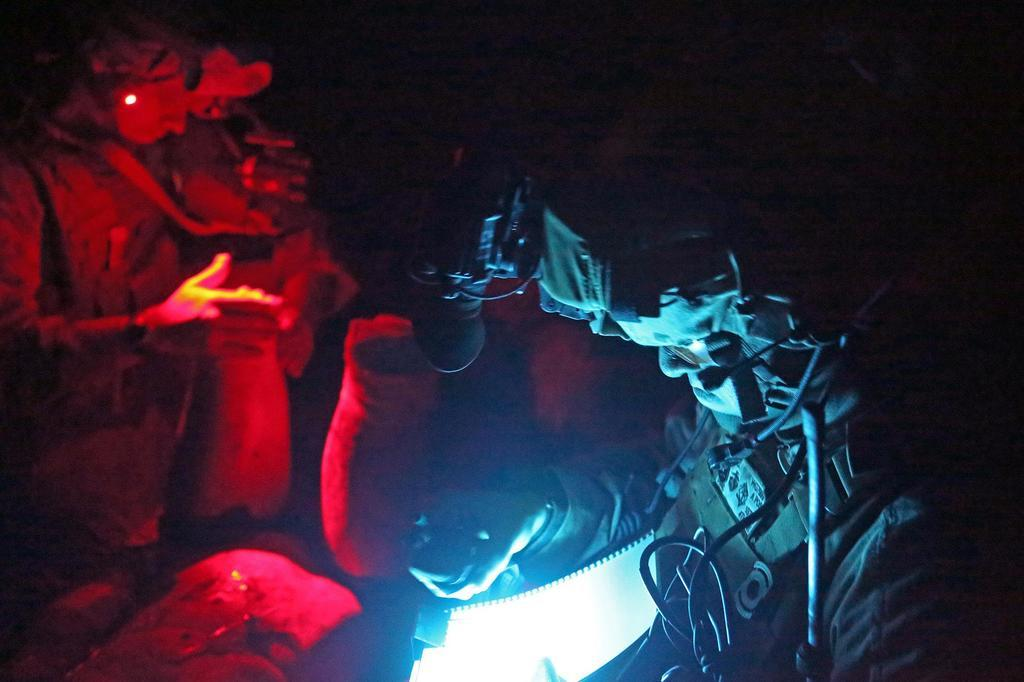What is the overall lighting condition in the image? The image is dark. Can you describe the subjects in the image? There are people in the image. How many dolls can be seen playing with the sheep in the image? There are no dolls or sheep present in the image; it only features people in a dark setting. 